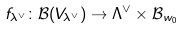Convert formula to latex. <formula><loc_0><loc_0><loc_500><loc_500>f _ { \lambda ^ { \vee } } \colon { \mathcal { B } } ( V _ { \lambda ^ { \vee } } ) \to \Lambda ^ { \vee } \times { \mathcal { B } } _ { w _ { 0 } }</formula> 